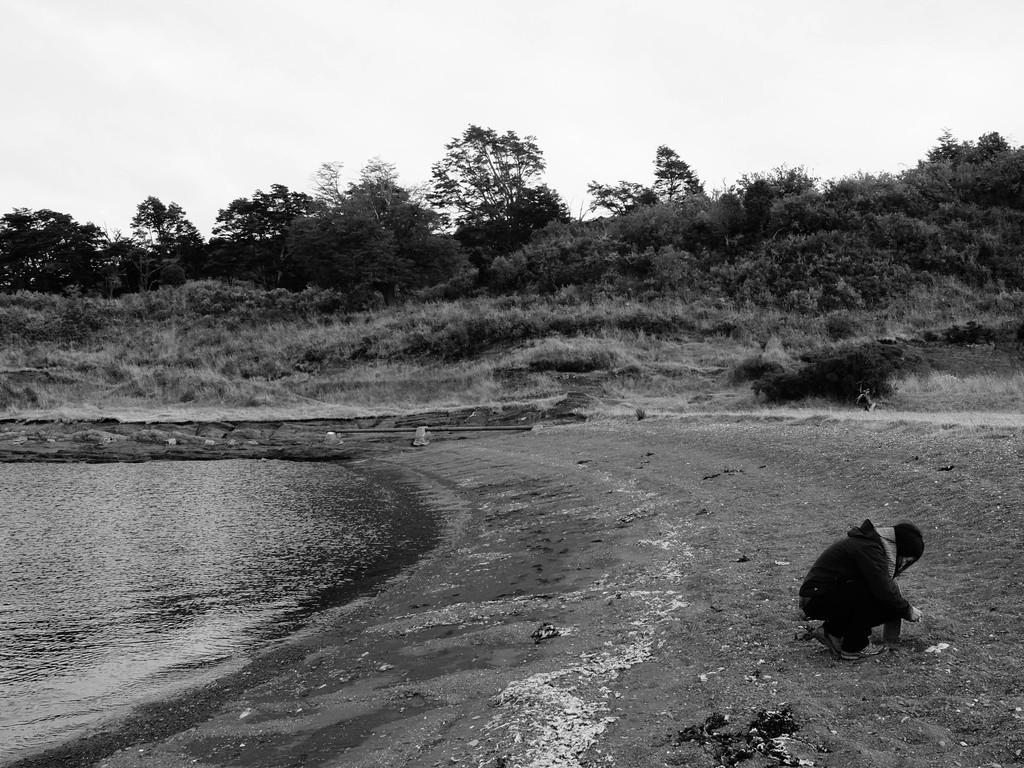What is the person in the image doing? There is a person sitting on the ground on the right side of the image. What can be seen on the left side of the image? There is a river on the left side of the image. What type of vegetation is visible in the background of the image? There are trees in the background of the image. What is visible in the background of the image besides the trees? The sky is visible in the background of the image. What type of curtain is hanging from the trees in the image? There is no curtain present in the image; it features a person sitting on the ground, a river, trees, and the sky. What angle is the image taken from? The angle from which the image is taken is not mentioned in the provided facts, so it cannot be determined. 